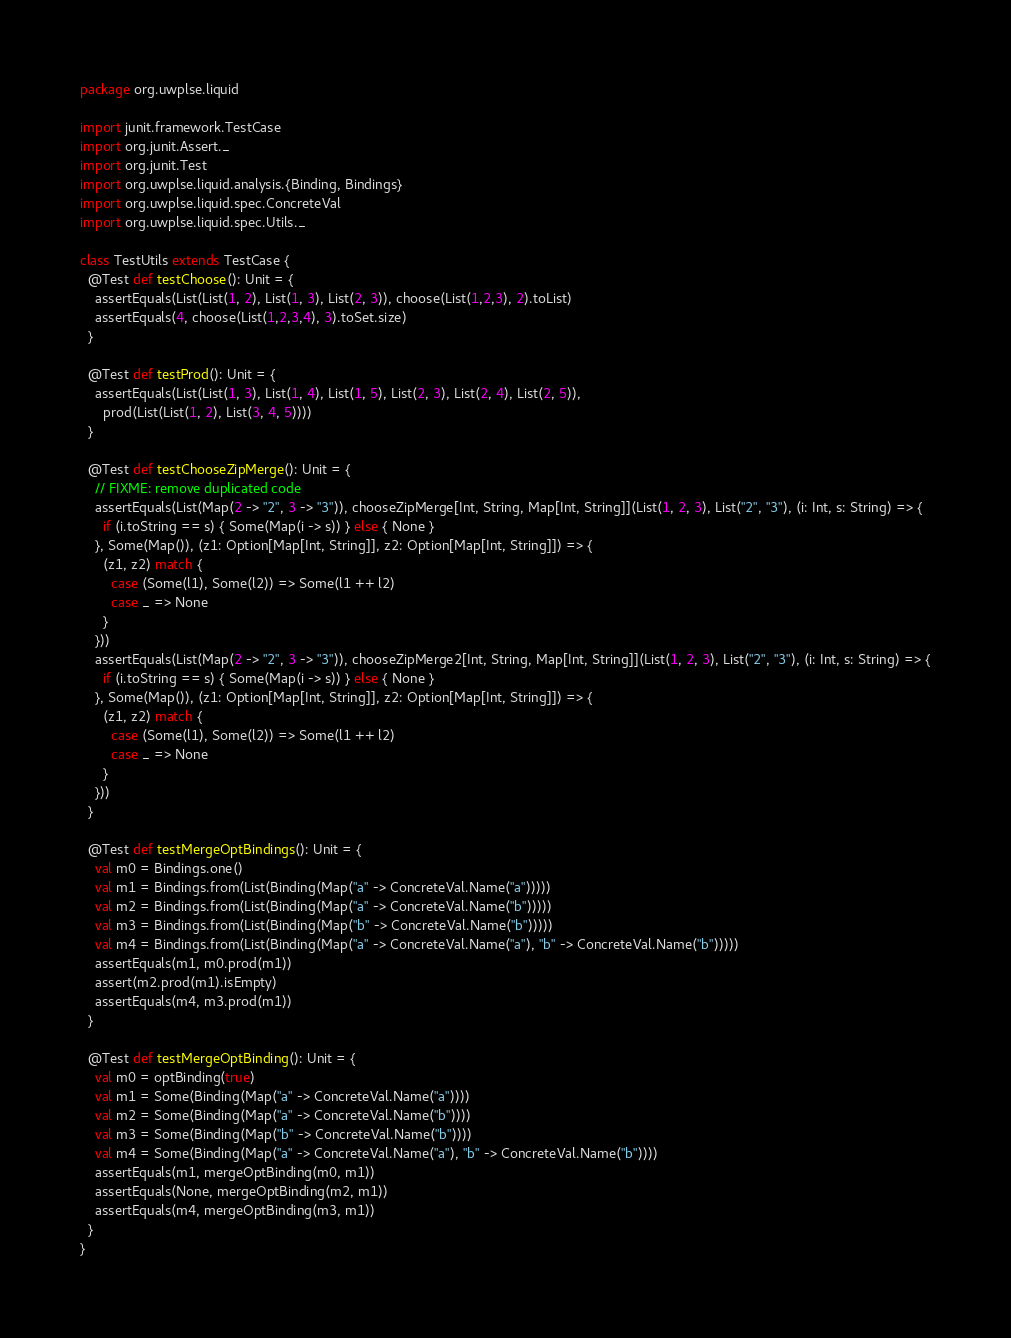<code> <loc_0><loc_0><loc_500><loc_500><_Scala_>package org.uwplse.liquid

import junit.framework.TestCase
import org.junit.Assert._
import org.junit.Test
import org.uwplse.liquid.analysis.{Binding, Bindings}
import org.uwplse.liquid.spec.ConcreteVal
import org.uwplse.liquid.spec.Utils._

class TestUtils extends TestCase {
  @Test def testChoose(): Unit = {
    assertEquals(List(List(1, 2), List(1, 3), List(2, 3)), choose(List(1,2,3), 2).toList)
    assertEquals(4, choose(List(1,2,3,4), 3).toSet.size)
  }

  @Test def testProd(): Unit = {
    assertEquals(List(List(1, 3), List(1, 4), List(1, 5), List(2, 3), List(2, 4), List(2, 5)),
      prod(List(List(1, 2), List(3, 4, 5))))
  }

  @Test def testChooseZipMerge(): Unit = {
    // FIXME: remove duplicated code
    assertEquals(List(Map(2 -> "2", 3 -> "3")), chooseZipMerge[Int, String, Map[Int, String]](List(1, 2, 3), List("2", "3"), (i: Int, s: String) => {
      if (i.toString == s) { Some(Map(i -> s)) } else { None }
    }, Some(Map()), (z1: Option[Map[Int, String]], z2: Option[Map[Int, String]]) => {
      (z1, z2) match {
        case (Some(l1), Some(l2)) => Some(l1 ++ l2)
        case _ => None
      }
    }))
    assertEquals(List(Map(2 -> "2", 3 -> "3")), chooseZipMerge2[Int, String, Map[Int, String]](List(1, 2, 3), List("2", "3"), (i: Int, s: String) => {
      if (i.toString == s) { Some(Map(i -> s)) } else { None }
    }, Some(Map()), (z1: Option[Map[Int, String]], z2: Option[Map[Int, String]]) => {
      (z1, z2) match {
        case (Some(l1), Some(l2)) => Some(l1 ++ l2)
        case _ => None
      }
    }))
  }

  @Test def testMergeOptBindings(): Unit = {
    val m0 = Bindings.one()
    val m1 = Bindings.from(List(Binding(Map("a" -> ConcreteVal.Name("a")))))
    val m2 = Bindings.from(List(Binding(Map("a" -> ConcreteVal.Name("b")))))
    val m3 = Bindings.from(List(Binding(Map("b" -> ConcreteVal.Name("b")))))
    val m4 = Bindings.from(List(Binding(Map("a" -> ConcreteVal.Name("a"), "b" -> ConcreteVal.Name("b")))))
    assertEquals(m1, m0.prod(m1))
    assert(m2.prod(m1).isEmpty)
    assertEquals(m4, m3.prod(m1))
  }

  @Test def testMergeOptBinding(): Unit = {
    val m0 = optBinding(true)
    val m1 = Some(Binding(Map("a" -> ConcreteVal.Name("a"))))
    val m2 = Some(Binding(Map("a" -> ConcreteVal.Name("b"))))
    val m3 = Some(Binding(Map("b" -> ConcreteVal.Name("b"))))
    val m4 = Some(Binding(Map("a" -> ConcreteVal.Name("a"), "b" -> ConcreteVal.Name("b"))))
    assertEquals(m1, mergeOptBinding(m0, m1))
    assertEquals(None, mergeOptBinding(m2, m1))
    assertEquals(m4, mergeOptBinding(m3, m1))
  }
}</code> 